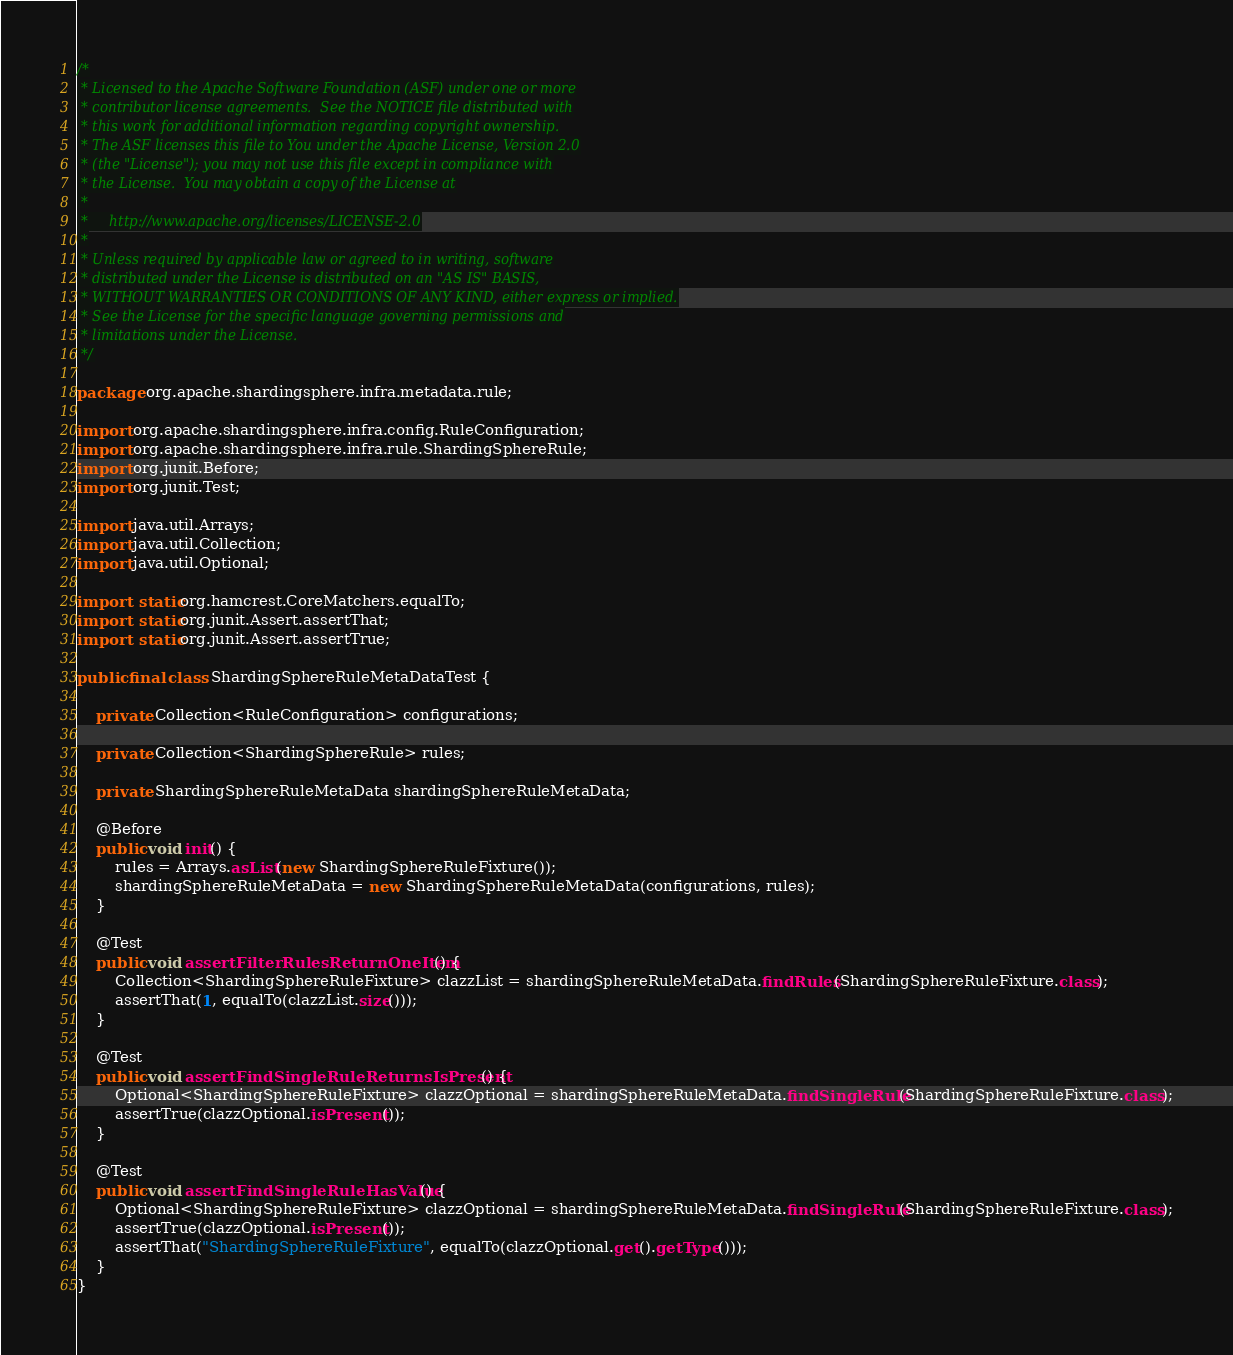<code> <loc_0><loc_0><loc_500><loc_500><_Java_>/*
 * Licensed to the Apache Software Foundation (ASF) under one or more
 * contributor license agreements.  See the NOTICE file distributed with
 * this work for additional information regarding copyright ownership.
 * The ASF licenses this file to You under the Apache License, Version 2.0
 * (the "License"); you may not use this file except in compliance with
 * the License.  You may obtain a copy of the License at
 *
 *     http://www.apache.org/licenses/LICENSE-2.0
 *
 * Unless required by applicable law or agreed to in writing, software
 * distributed under the License is distributed on an "AS IS" BASIS,
 * WITHOUT WARRANTIES OR CONDITIONS OF ANY KIND, either express or implied.
 * See the License for the specific language governing permissions and
 * limitations under the License.
 */

package org.apache.shardingsphere.infra.metadata.rule;

import org.apache.shardingsphere.infra.config.RuleConfiguration;
import org.apache.shardingsphere.infra.rule.ShardingSphereRule;
import org.junit.Before;
import org.junit.Test;

import java.util.Arrays;
import java.util.Collection;
import java.util.Optional;

import static org.hamcrest.CoreMatchers.equalTo;
import static org.junit.Assert.assertThat;
import static org.junit.Assert.assertTrue;

public final class ShardingSphereRuleMetaDataTest {
    
    private Collection<RuleConfiguration> configurations;
    
    private Collection<ShardingSphereRule> rules;
    
    private ShardingSphereRuleMetaData shardingSphereRuleMetaData;
    
    @Before
    public void init() {
        rules = Arrays.asList(new ShardingSphereRuleFixture());
        shardingSphereRuleMetaData = new ShardingSphereRuleMetaData(configurations, rules);
    }
    
    @Test
    public void assertFilterRulesReturnOneItem() {
        Collection<ShardingSphereRuleFixture> clazzList = shardingSphereRuleMetaData.findRules(ShardingSphereRuleFixture.class);
        assertThat(1, equalTo(clazzList.size()));
    }
    
    @Test
    public void assertFindSingleRuleReturnsIsPresent() {
        Optional<ShardingSphereRuleFixture> clazzOptional = shardingSphereRuleMetaData.findSingleRule(ShardingSphereRuleFixture.class);
        assertTrue(clazzOptional.isPresent());
    }
    
    @Test
    public void assertFindSingleRuleHasValue() {
        Optional<ShardingSphereRuleFixture> clazzOptional = shardingSphereRuleMetaData.findSingleRule(ShardingSphereRuleFixture.class);
        assertTrue(clazzOptional.isPresent());
        assertThat("ShardingSphereRuleFixture", equalTo(clazzOptional.get().getType()));
    }
}
</code> 